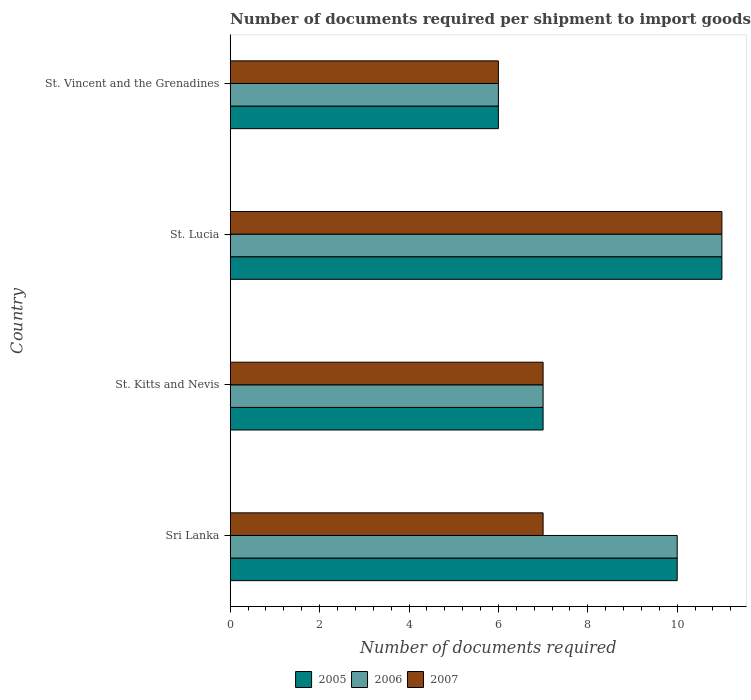Are the number of bars per tick equal to the number of legend labels?
Your answer should be compact. Yes. Are the number of bars on each tick of the Y-axis equal?
Ensure brevity in your answer.  Yes. How many bars are there on the 2nd tick from the bottom?
Make the answer very short. 3. What is the label of the 4th group of bars from the top?
Offer a very short reply. Sri Lanka. In how many cases, is the number of bars for a given country not equal to the number of legend labels?
Make the answer very short. 0. In which country was the number of documents required per shipment to import goods in 2007 maximum?
Keep it short and to the point. St. Lucia. In which country was the number of documents required per shipment to import goods in 2006 minimum?
Your answer should be very brief. St. Vincent and the Grenadines. What is the total number of documents required per shipment to import goods in 2005 in the graph?
Offer a terse response. 34. What is the difference between the number of documents required per shipment to import goods in 2006 in St. Kitts and Nevis and the number of documents required per shipment to import goods in 2005 in St. Lucia?
Offer a very short reply. -4. What is the difference between the number of documents required per shipment to import goods in 2006 and number of documents required per shipment to import goods in 2005 in St. Lucia?
Your answer should be compact. 0. What is the ratio of the number of documents required per shipment to import goods in 2006 in St. Lucia to that in St. Vincent and the Grenadines?
Make the answer very short. 1.83. Is the number of documents required per shipment to import goods in 2005 in St. Lucia less than that in St. Vincent and the Grenadines?
Ensure brevity in your answer.  No. Is the difference between the number of documents required per shipment to import goods in 2006 in Sri Lanka and St. Kitts and Nevis greater than the difference between the number of documents required per shipment to import goods in 2005 in Sri Lanka and St. Kitts and Nevis?
Keep it short and to the point. No. What is the difference between the highest and the second highest number of documents required per shipment to import goods in 2007?
Give a very brief answer. 4. What is the difference between the highest and the lowest number of documents required per shipment to import goods in 2005?
Your answer should be compact. 5. In how many countries, is the number of documents required per shipment to import goods in 2006 greater than the average number of documents required per shipment to import goods in 2006 taken over all countries?
Your answer should be very brief. 2. Is the sum of the number of documents required per shipment to import goods in 2006 in St. Lucia and St. Vincent and the Grenadines greater than the maximum number of documents required per shipment to import goods in 2005 across all countries?
Your response must be concise. Yes. What does the 2nd bar from the top in Sri Lanka represents?
Provide a short and direct response. 2006. Is it the case that in every country, the sum of the number of documents required per shipment to import goods in 2006 and number of documents required per shipment to import goods in 2007 is greater than the number of documents required per shipment to import goods in 2005?
Make the answer very short. Yes. Are all the bars in the graph horizontal?
Offer a very short reply. Yes. Are the values on the major ticks of X-axis written in scientific E-notation?
Provide a succinct answer. No. Where does the legend appear in the graph?
Offer a very short reply. Bottom center. How many legend labels are there?
Provide a succinct answer. 3. How are the legend labels stacked?
Keep it short and to the point. Horizontal. What is the title of the graph?
Your response must be concise. Number of documents required per shipment to import goods. What is the label or title of the X-axis?
Provide a succinct answer. Number of documents required. What is the label or title of the Y-axis?
Your answer should be very brief. Country. What is the Number of documents required of 2005 in Sri Lanka?
Your answer should be compact. 10. What is the Number of documents required in 2007 in Sri Lanka?
Ensure brevity in your answer.  7. What is the Number of documents required of 2006 in St. Kitts and Nevis?
Keep it short and to the point. 7. What is the Number of documents required in 2007 in St. Kitts and Nevis?
Offer a very short reply. 7. What is the Number of documents required in 2007 in St. Lucia?
Offer a terse response. 11. What is the Number of documents required in 2006 in St. Vincent and the Grenadines?
Make the answer very short. 6. What is the Number of documents required of 2007 in St. Vincent and the Grenadines?
Ensure brevity in your answer.  6. Across all countries, what is the maximum Number of documents required in 2005?
Make the answer very short. 11. Across all countries, what is the minimum Number of documents required of 2005?
Your answer should be compact. 6. What is the total Number of documents required in 2005 in the graph?
Ensure brevity in your answer.  34. What is the total Number of documents required of 2006 in the graph?
Keep it short and to the point. 34. What is the difference between the Number of documents required in 2006 in Sri Lanka and that in St. Kitts and Nevis?
Make the answer very short. 3. What is the difference between the Number of documents required of 2006 in Sri Lanka and that in St. Lucia?
Offer a very short reply. -1. What is the difference between the Number of documents required in 2005 in Sri Lanka and that in St. Vincent and the Grenadines?
Offer a very short reply. 4. What is the difference between the Number of documents required in 2006 in St. Kitts and Nevis and that in St. Lucia?
Your answer should be very brief. -4. What is the difference between the Number of documents required of 2007 in St. Kitts and Nevis and that in St. Vincent and the Grenadines?
Keep it short and to the point. 1. What is the difference between the Number of documents required of 2005 in St. Lucia and that in St. Vincent and the Grenadines?
Give a very brief answer. 5. What is the difference between the Number of documents required of 2005 in Sri Lanka and the Number of documents required of 2006 in St. Kitts and Nevis?
Provide a short and direct response. 3. What is the difference between the Number of documents required in 2005 in Sri Lanka and the Number of documents required in 2007 in St. Kitts and Nevis?
Ensure brevity in your answer.  3. What is the difference between the Number of documents required in 2005 in Sri Lanka and the Number of documents required in 2006 in St. Lucia?
Make the answer very short. -1. What is the difference between the Number of documents required of 2005 in Sri Lanka and the Number of documents required of 2007 in St. Lucia?
Keep it short and to the point. -1. What is the difference between the Number of documents required in 2006 in Sri Lanka and the Number of documents required in 2007 in St. Lucia?
Provide a succinct answer. -1. What is the difference between the Number of documents required of 2005 in Sri Lanka and the Number of documents required of 2006 in St. Vincent and the Grenadines?
Your response must be concise. 4. What is the difference between the Number of documents required of 2006 in St. Kitts and Nevis and the Number of documents required of 2007 in St. Lucia?
Ensure brevity in your answer.  -4. What is the difference between the Number of documents required of 2005 in St. Kitts and Nevis and the Number of documents required of 2006 in St. Vincent and the Grenadines?
Keep it short and to the point. 1. What is the difference between the Number of documents required of 2005 in St. Lucia and the Number of documents required of 2006 in St. Vincent and the Grenadines?
Your answer should be compact. 5. What is the difference between the Number of documents required of 2005 in St. Lucia and the Number of documents required of 2007 in St. Vincent and the Grenadines?
Your answer should be very brief. 5. What is the difference between the Number of documents required of 2006 in St. Lucia and the Number of documents required of 2007 in St. Vincent and the Grenadines?
Provide a short and direct response. 5. What is the average Number of documents required in 2007 per country?
Your answer should be compact. 7.75. What is the difference between the Number of documents required in 2005 and Number of documents required in 2006 in Sri Lanka?
Ensure brevity in your answer.  0. What is the difference between the Number of documents required in 2005 and Number of documents required in 2006 in St. Kitts and Nevis?
Your response must be concise. 0. What is the difference between the Number of documents required of 2005 and Number of documents required of 2006 in St. Lucia?
Your response must be concise. 0. What is the difference between the Number of documents required in 2006 and Number of documents required in 2007 in St. Lucia?
Provide a succinct answer. 0. What is the difference between the Number of documents required in 2005 and Number of documents required in 2006 in St. Vincent and the Grenadines?
Offer a very short reply. 0. What is the difference between the Number of documents required of 2005 and Number of documents required of 2007 in St. Vincent and the Grenadines?
Provide a short and direct response. 0. What is the difference between the Number of documents required of 2006 and Number of documents required of 2007 in St. Vincent and the Grenadines?
Provide a short and direct response. 0. What is the ratio of the Number of documents required of 2005 in Sri Lanka to that in St. Kitts and Nevis?
Ensure brevity in your answer.  1.43. What is the ratio of the Number of documents required of 2006 in Sri Lanka to that in St. Kitts and Nevis?
Make the answer very short. 1.43. What is the ratio of the Number of documents required of 2007 in Sri Lanka to that in St. Kitts and Nevis?
Provide a short and direct response. 1. What is the ratio of the Number of documents required of 2005 in Sri Lanka to that in St. Lucia?
Make the answer very short. 0.91. What is the ratio of the Number of documents required in 2006 in Sri Lanka to that in St. Lucia?
Offer a terse response. 0.91. What is the ratio of the Number of documents required of 2007 in Sri Lanka to that in St. Lucia?
Offer a very short reply. 0.64. What is the ratio of the Number of documents required of 2006 in Sri Lanka to that in St. Vincent and the Grenadines?
Offer a terse response. 1.67. What is the ratio of the Number of documents required in 2005 in St. Kitts and Nevis to that in St. Lucia?
Offer a terse response. 0.64. What is the ratio of the Number of documents required of 2006 in St. Kitts and Nevis to that in St. Lucia?
Your answer should be very brief. 0.64. What is the ratio of the Number of documents required of 2007 in St. Kitts and Nevis to that in St. Lucia?
Your answer should be compact. 0.64. What is the ratio of the Number of documents required of 2007 in St. Kitts and Nevis to that in St. Vincent and the Grenadines?
Provide a succinct answer. 1.17. What is the ratio of the Number of documents required of 2005 in St. Lucia to that in St. Vincent and the Grenadines?
Provide a succinct answer. 1.83. What is the ratio of the Number of documents required in 2006 in St. Lucia to that in St. Vincent and the Grenadines?
Offer a terse response. 1.83. What is the ratio of the Number of documents required in 2007 in St. Lucia to that in St. Vincent and the Grenadines?
Your answer should be very brief. 1.83. What is the difference between the highest and the lowest Number of documents required in 2005?
Offer a very short reply. 5. 